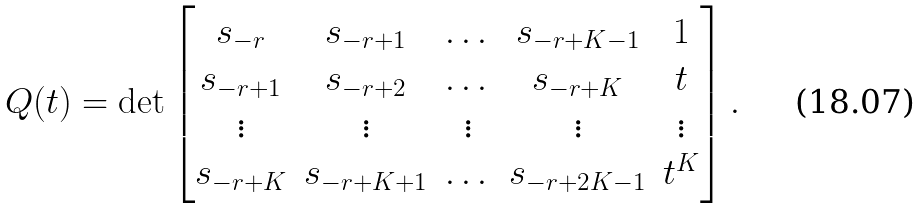Convert formula to latex. <formula><loc_0><loc_0><loc_500><loc_500>Q ( t ) = \det \begin{bmatrix} s _ { - r } & s _ { - r + 1 } & \dots & s _ { - r + K - 1 } & 1 \\ s _ { - r + 1 } & s _ { - r + 2 } & \dots & s _ { - r + K } & t \\ \vdots & \vdots & \vdots & \vdots & \vdots \\ s _ { - r + K } & s _ { - r + K + 1 } & \dots & s _ { - r + 2 K - 1 } & t ^ { K } \end{bmatrix} .</formula> 